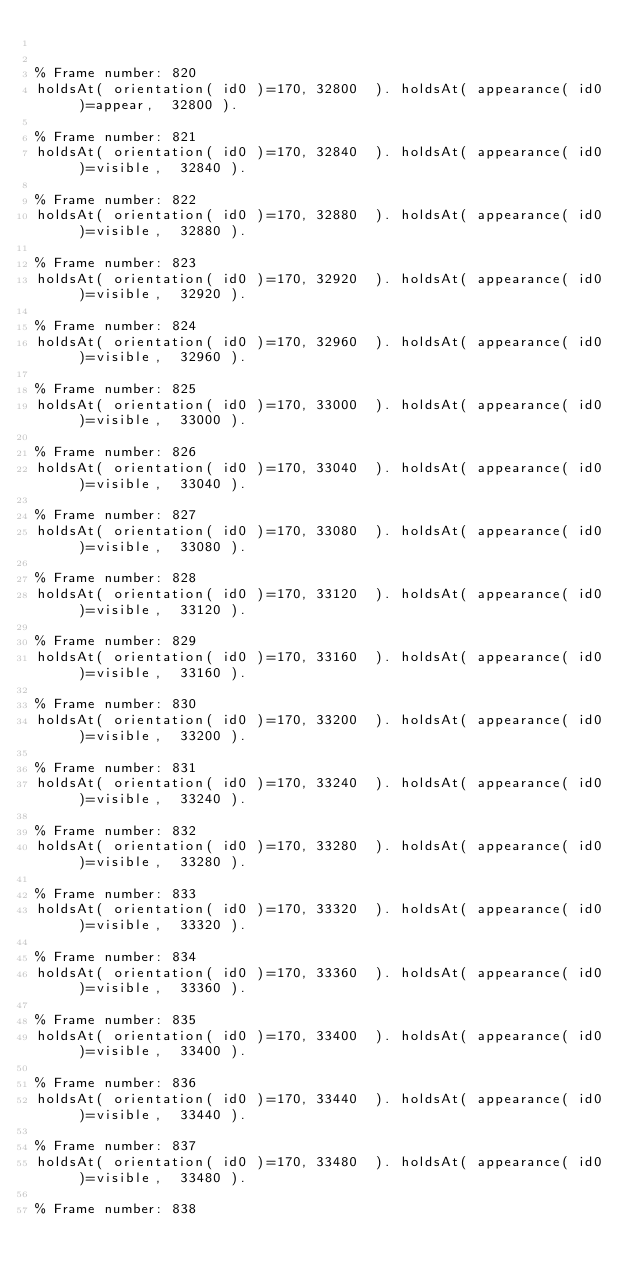Convert code to text. <code><loc_0><loc_0><loc_500><loc_500><_Perl_>

% Frame number: 820
holdsAt( orientation( id0 )=170, 32800  ). holdsAt( appearance( id0 )=appear,  32800 ).

% Frame number: 821
holdsAt( orientation( id0 )=170, 32840  ). holdsAt( appearance( id0 )=visible,  32840 ).

% Frame number: 822
holdsAt( orientation( id0 )=170, 32880  ). holdsAt( appearance( id0 )=visible,  32880 ).

% Frame number: 823
holdsAt( orientation( id0 )=170, 32920  ). holdsAt( appearance( id0 )=visible,  32920 ).

% Frame number: 824
holdsAt( orientation( id0 )=170, 32960  ). holdsAt( appearance( id0 )=visible,  32960 ).

% Frame number: 825
holdsAt( orientation( id0 )=170, 33000  ). holdsAt( appearance( id0 )=visible,  33000 ).

% Frame number: 826
holdsAt( orientation( id0 )=170, 33040  ). holdsAt( appearance( id0 )=visible,  33040 ).

% Frame number: 827
holdsAt( orientation( id0 )=170, 33080  ). holdsAt( appearance( id0 )=visible,  33080 ).

% Frame number: 828
holdsAt( orientation( id0 )=170, 33120  ). holdsAt( appearance( id0 )=visible,  33120 ).

% Frame number: 829
holdsAt( orientation( id0 )=170, 33160  ). holdsAt( appearance( id0 )=visible,  33160 ).

% Frame number: 830
holdsAt( orientation( id0 )=170, 33200  ). holdsAt( appearance( id0 )=visible,  33200 ).

% Frame number: 831
holdsAt( orientation( id0 )=170, 33240  ). holdsAt( appearance( id0 )=visible,  33240 ).

% Frame number: 832
holdsAt( orientation( id0 )=170, 33280  ). holdsAt( appearance( id0 )=visible,  33280 ).

% Frame number: 833
holdsAt( orientation( id0 )=170, 33320  ). holdsAt( appearance( id0 )=visible,  33320 ).

% Frame number: 834
holdsAt( orientation( id0 )=170, 33360  ). holdsAt( appearance( id0 )=visible,  33360 ).

% Frame number: 835
holdsAt( orientation( id0 )=170, 33400  ). holdsAt( appearance( id0 )=visible,  33400 ).

% Frame number: 836
holdsAt( orientation( id0 )=170, 33440  ). holdsAt( appearance( id0 )=visible,  33440 ).

% Frame number: 837
holdsAt( orientation( id0 )=170, 33480  ). holdsAt( appearance( id0 )=visible,  33480 ).

% Frame number: 838</code> 